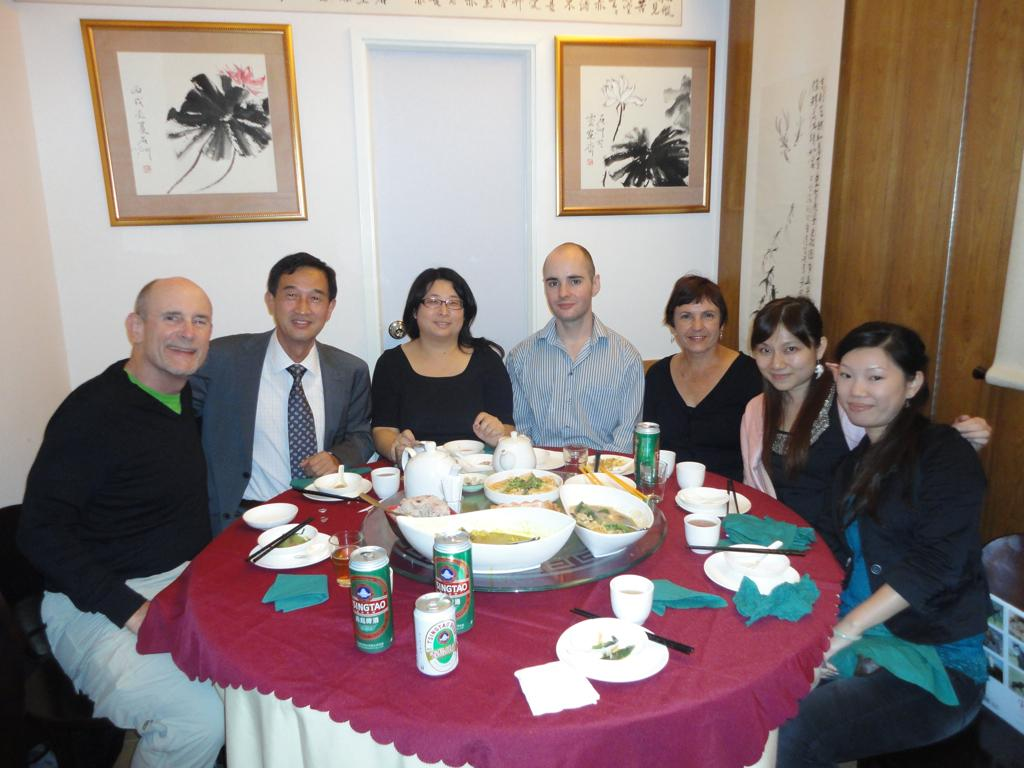What is happening in the image involving a group of people? There is a group of people sitting around a dining table in the image. What are the people doing at the dining table? The people are laughing and enjoying each other's company. What can be seen on the dining table? There are food items on the dining table. What is visible on the wall behind the people? There are photographs on the wall behind them. What is the setting of the image? The image shows a group of people sitting at a dining table, with a wall visible in the background. What type of trouble is the queen experiencing in the image? There is no queen or any indication of trouble in the image; it features a group of people sitting at a dining table. 